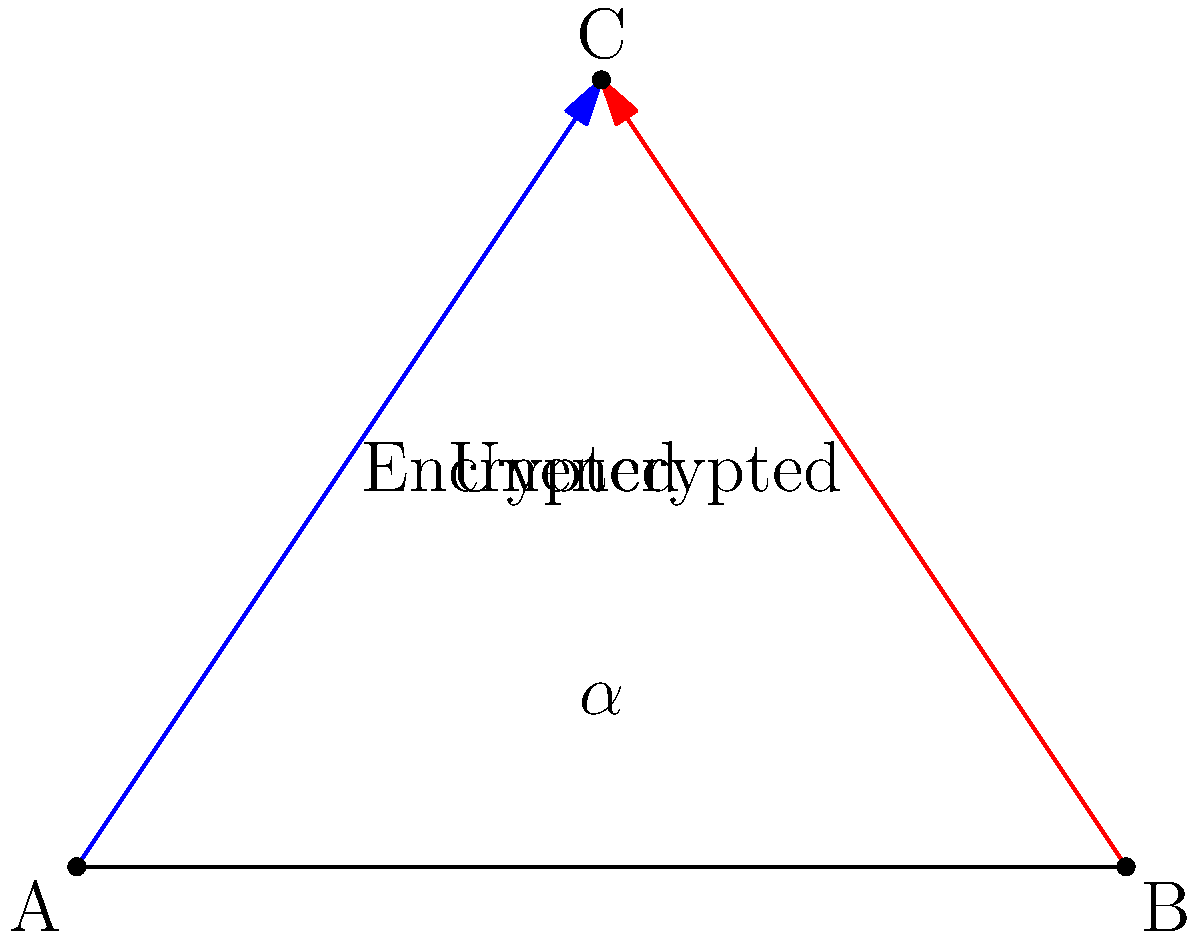In the diagram, two data paths intersect at point C. The blue line represents the encrypted data path, while the red line represents the unencrypted data path. If the angle between these paths is denoted as $\alpha$, and the triangle ABC is equilateral, what is the value of $\alpha$? To solve this problem, let's follow these steps:

1) In an equilateral triangle, all angles are equal and measure 60°.

2) The angle $\alpha$ is an exterior angle of the triangle at point C.

3) An exterior angle of a triangle is supplementary to the interior angle at the same vertex. This means:
   $\alpha + 60° = 180°$

4) We can solve this equation for $\alpha$:
   $\alpha = 180° - 60° = 120°$

5) Therefore, the angle between the encrypted and unencrypted data paths is 120°.

This geometric representation illustrates how encrypted and unencrypted data paths might diverge, potentially highlighting the importance of secure data transmission for someone cautious about proxy services.
Answer: $120°$ 